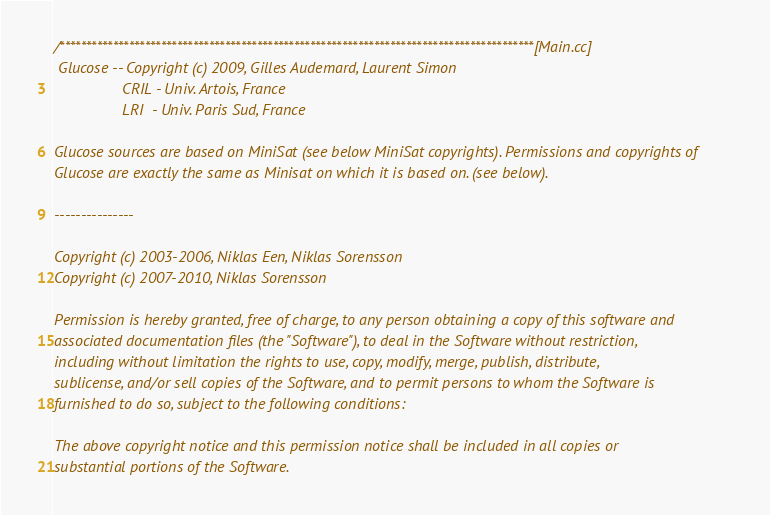Convert code to text. <code><loc_0><loc_0><loc_500><loc_500><_C++_>/*****************************************************************************************[Main.cc]
 Glucose -- Copyright (c) 2009, Gilles Audemard, Laurent Simon
				CRIL - Univ. Artois, France
				LRI  - Univ. Paris Sud, France
 
Glucose sources are based on MiniSat (see below MiniSat copyrights). Permissions and copyrights of
Glucose are exactly the same as Minisat on which it is based on. (see below).

---------------

Copyright (c) 2003-2006, Niklas Een, Niklas Sorensson
Copyright (c) 2007-2010, Niklas Sorensson

Permission is hereby granted, free of charge, to any person obtaining a copy of this software and
associated documentation files (the "Software"), to deal in the Software without restriction,
including without limitation the rights to use, copy, modify, merge, publish, distribute,
sublicense, and/or sell copies of the Software, and to permit persons to whom the Software is
furnished to do so, subject to the following conditions:

The above copyright notice and this permission notice shall be included in all copies or
substantial portions of the Software.
</code> 